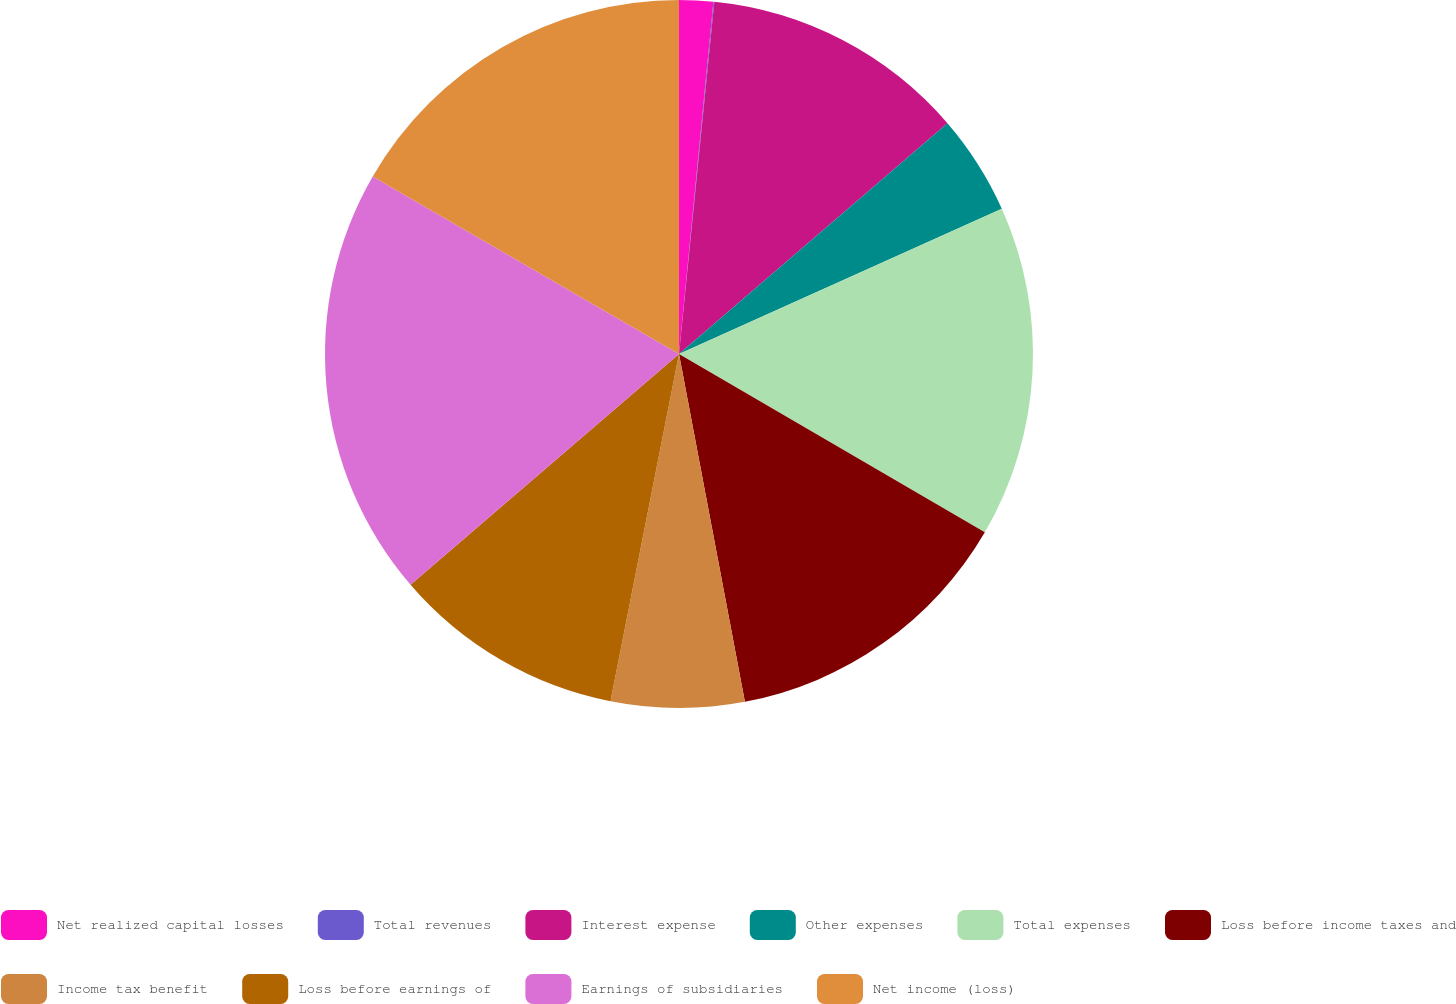Convert chart. <chart><loc_0><loc_0><loc_500><loc_500><pie_chart><fcel>Net realized capital losses<fcel>Total revenues<fcel>Interest expense<fcel>Other expenses<fcel>Total expenses<fcel>Loss before income taxes and<fcel>Income tax benefit<fcel>Loss before earnings of<fcel>Earnings of subsidiaries<fcel>Net income (loss)<nl><fcel>1.55%<fcel>0.04%<fcel>12.11%<fcel>4.57%<fcel>15.13%<fcel>13.62%<fcel>6.08%<fcel>10.6%<fcel>19.66%<fcel>16.64%<nl></chart> 